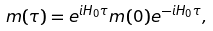Convert formula to latex. <formula><loc_0><loc_0><loc_500><loc_500>m ( \tau ) = e ^ { i H _ { 0 } \tau } m ( 0 ) e ^ { - i H _ { 0 } \tau } ,</formula> 